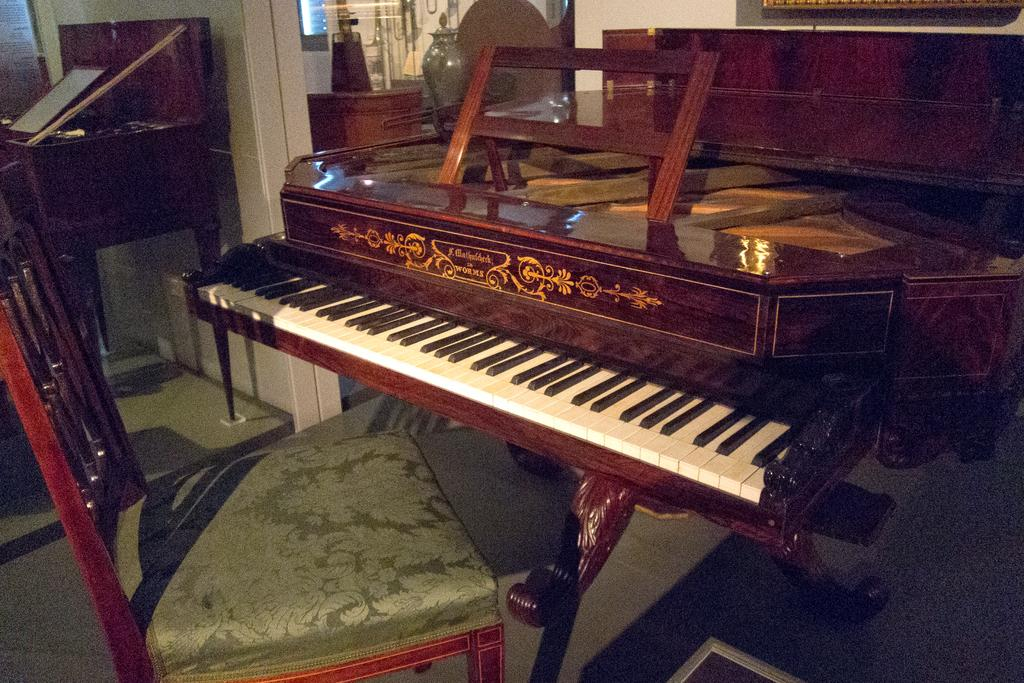What is the main object in the image? There is a piano in the image. Where is the piano located in the image? The piano is placed at the right side of the image. Is there any furniture near the piano? Yes, there is a chair in front of the piano. What type of flower is growing in the pot next to the piano? There is no pot or flower present in the image; it only features a piano and a chair. 